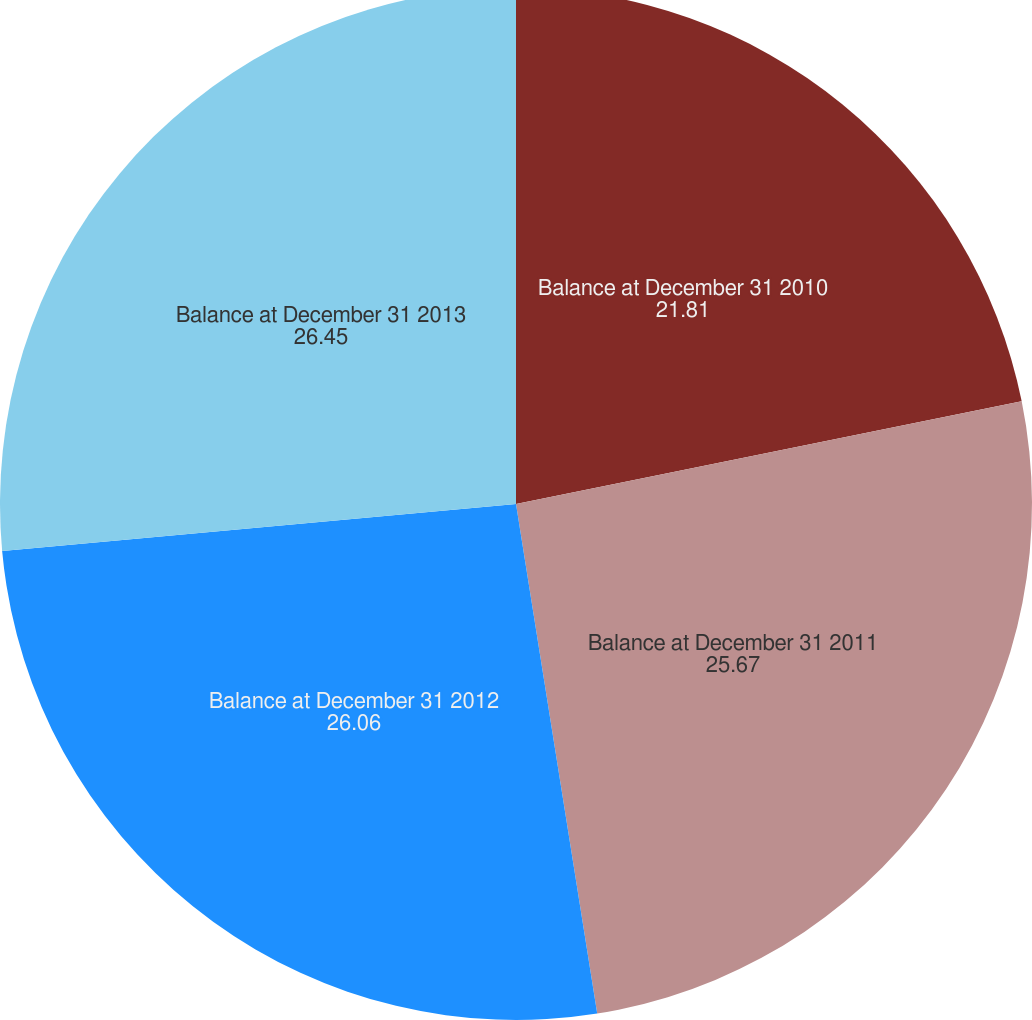Convert chart to OTSL. <chart><loc_0><loc_0><loc_500><loc_500><pie_chart><fcel>Balance at December 31 2010<fcel>Balance at December 31 2011<fcel>Balance at December 31 2012<fcel>Balance at December 31 2013<nl><fcel>21.81%<fcel>25.67%<fcel>26.06%<fcel>26.45%<nl></chart> 